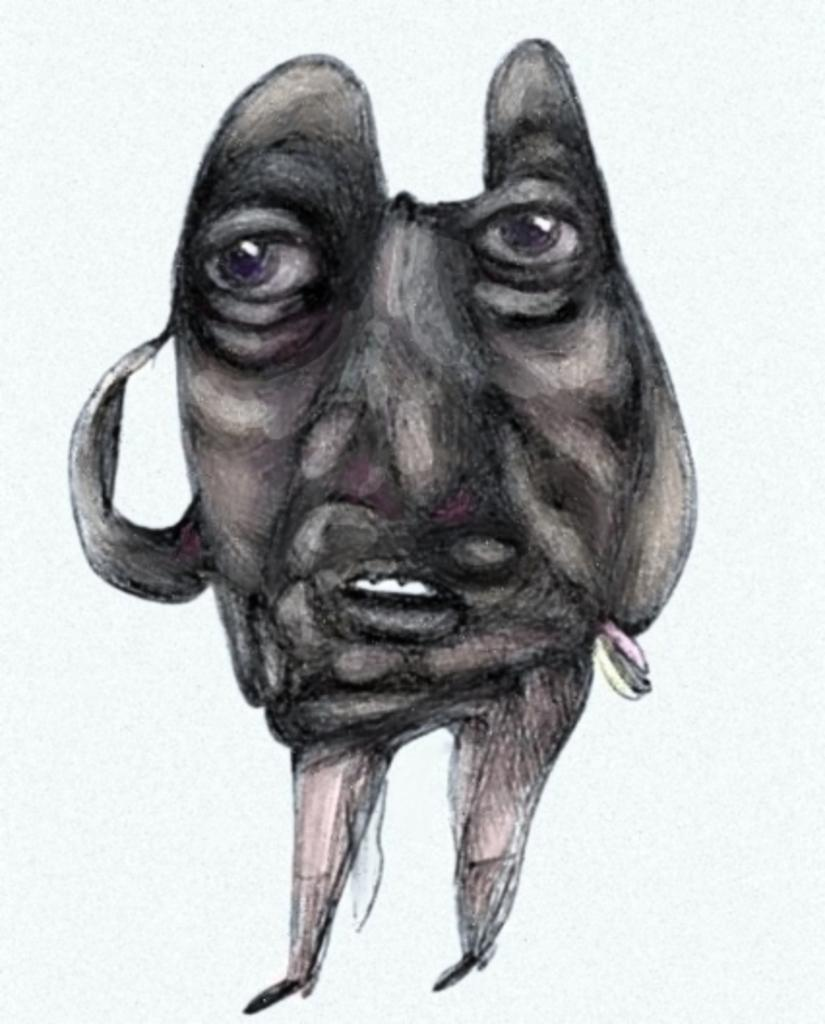What is the main subject of the sketch in the image? The sketch depicts a person's face. Are there any other body parts included in the sketch? Yes, the sketch also includes the person's legs. How does the person in the sketch blow a bubble with their elbow? There is no person blowing a bubble with their elbow in the sketch; the sketch only depicts a person's face and legs. 